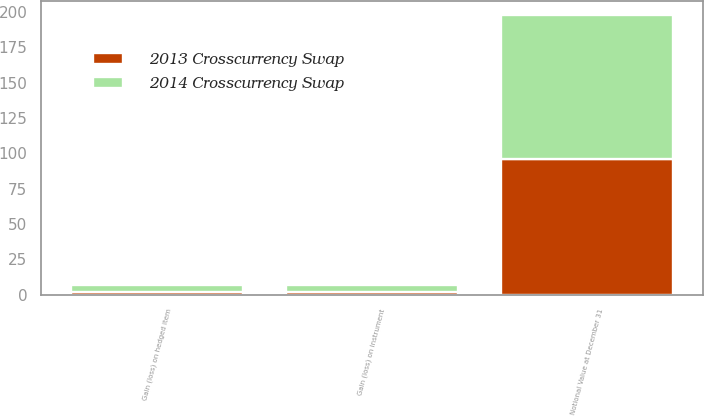Convert chart to OTSL. <chart><loc_0><loc_0><loc_500><loc_500><stacked_bar_chart><ecel><fcel>Notional Value at December 31<fcel>Gain (loss) on instrument<fcel>Gain (loss) on hedged item<nl><fcel>2014 Crosscurrency Swap<fcel>102<fcel>5<fcel>5<nl><fcel>2013 Crosscurrency Swap<fcel>96<fcel>2<fcel>2<nl></chart> 